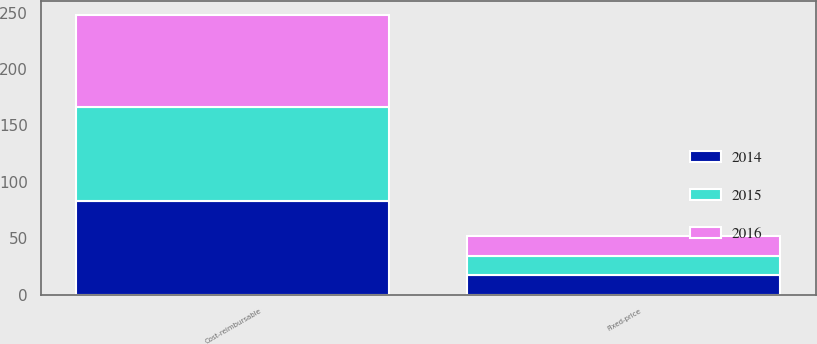Convert chart to OTSL. <chart><loc_0><loc_0><loc_500><loc_500><stacked_bar_chart><ecel><fcel>Cost-reimbursable<fcel>Fixed-price<nl><fcel>2016<fcel>82<fcel>18<nl><fcel>2015<fcel>83<fcel>17<nl><fcel>2014<fcel>83<fcel>17<nl></chart> 